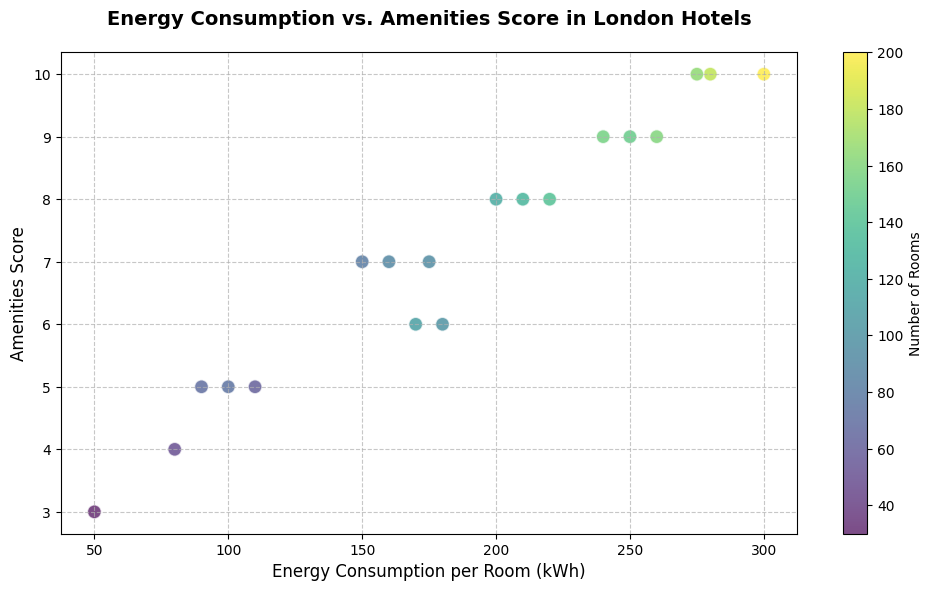What is the range of energy consumption per room observed across the hotels? The range is determined by subtracting the lowest value from the highest value. The lowest value is 50 kWh (Hotel O) and the highest value is 300 kWh (Hotel F), thus, 300 - 50 = 250 kWh.
Answer: 250 kWh Which hotel has the highest amenities score and how does its energy consumption per room compare to others on the plot? The hotel with the highest amenities score (10) is Hotel F (300 kWh), Hotel N (280 kWh), Hotel P (290 kWh), and Hotel T (275 kWh). Their energy consumptions are among the highest in the plot, indicating a positive correlation between higher amenities scores and higher energy consumption.
Answer: Among the highest energy consumption What is the average energy consumption per room for hotels with an amenities score of 8? To find the average, sum the energy consumptions of hotels with an amenities score of 8 and divide by the number of such hotels. Hotels with an amenities score of 8: Hotel A (200 kWh), Hotel I (210 kWh), and Hotel K (220 kWh). Sum is 200 + 210 + 220 = 630 kWh, and there are 3 hotels, so 630 / 3 = 210 kWh.
Answer: 210 kWh Between Hotel J and Hotel O, which has a lower energy consumption per room and by how many kilowatt-hours? Compare the energy consumption per room for Hotel J (80 kWh) and Hotel O (50 kWh). The difference is 80 - 50 = 30 kWh. Hotel O has lower energy consumption by 30 kWh.
Answer: Hotel O by 30 kWh In general, how does the number of rooms affect the position of the hotels on the scatter plot? The number of rooms is represented by color intensity. Hotels with more rooms tend to be shown in darker shades indicating their position with larger circles. These hotels are primarily positioned higher Energy consumption per room and amenities scores.
Answer: Darker circles with larger size indicate more rooms Which two hotels have the same amenities score but different energy consumption, and what are their values? Identify hotels with the same amenities score and compare their energy consumption. For instance, Hotel Q (175 kWh) and Hotel H (160 kWh) both have an amenities score of 7, but different energy consumptions: 175 kWh and 160 kWh respectively.
Answer: Hotel Q (175 kWh) and Hotel H (160 kWh) What trend is observed between energy consumption per room and amenities score? Observe the general direction of the scatter plot points. An increase in amenities score tends to coincide with an increase in energy consumption per room, indicating a positive correlation.
Answer: Positive correlation How does the energy consumption per room for Hotel D compare to Hotel S, and what can be inferred about their amenities score difference? By comparing Hotel D (180 kWh) and Hotel S (240 kWh), Hotel S has higher energy consumption per room. Hotel D has an amenities score of 6, while Hotel S has a score of 9. Notably, an increased amenities score appears to be associated with higher energy consumption.
Answer: Hotel D has lower energy consumption; higher amenities score correlates with higher energy consumption What is the median energy consumption per room for all the hotels presented? To find the median, list all energy values in ascending order and locate the middle value. Order: 50, 80, 90, 100, 110, 150, 160, 170, 175, 180, 200, 210, 220, 240, 250, 260, 275, 280, 290, 300. Middle values are 200 and 210, thus median is (200 + 210) / 2 = 205 kWh.
Answer: 205 kWh Which hotel stands out for having a noticeably low energy consumption per room and also a low amenities score? Based on the plot, Hotel O stands out with the lowest energy consumption per room (50 kWh) and a low amenities score (3).
Answer: Hotel O 